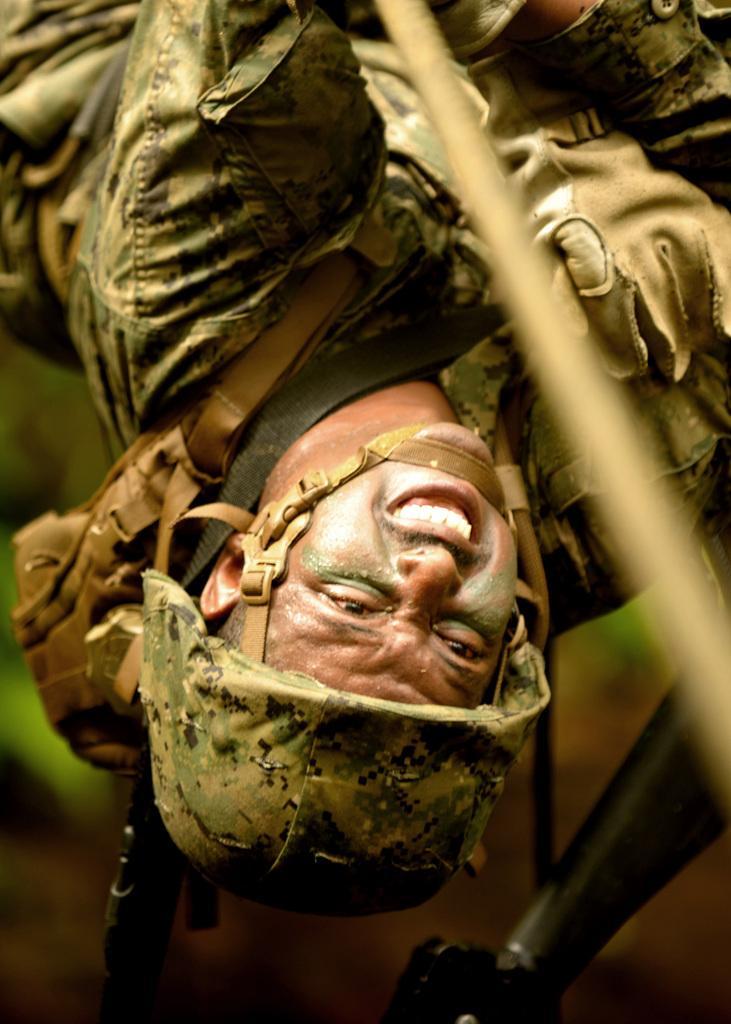In one or two sentences, can you explain what this image depicts? This man wore helmet, military dress and gloves. Background it is blur. 